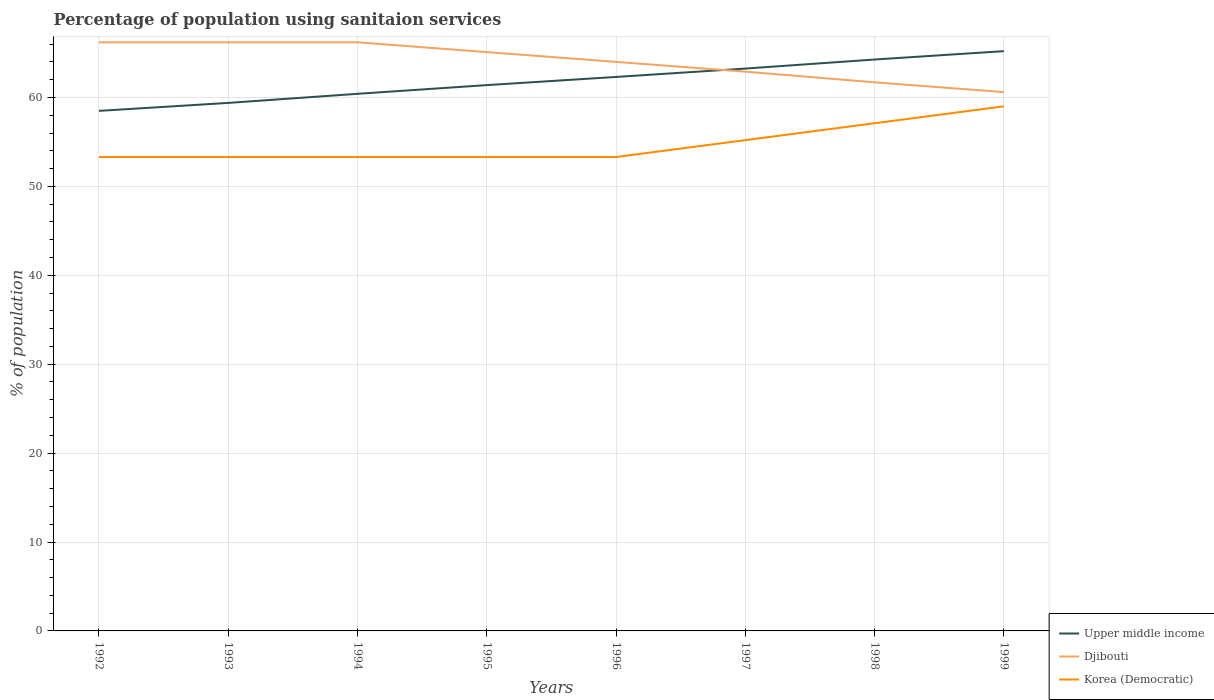How many different coloured lines are there?
Make the answer very short. 3. Across all years, what is the maximum percentage of population using sanitaion services in Djibouti?
Provide a short and direct response. 60.6. What is the total percentage of population using sanitaion services in Djibouti in the graph?
Provide a short and direct response. 5.6. What is the difference between the highest and the second highest percentage of population using sanitaion services in Djibouti?
Offer a terse response. 5.6. What is the difference between the highest and the lowest percentage of population using sanitaion services in Djibouti?
Your response must be concise. 4. How many lines are there?
Offer a terse response. 3. How many years are there in the graph?
Make the answer very short. 8. What is the difference between two consecutive major ticks on the Y-axis?
Your response must be concise. 10. Are the values on the major ticks of Y-axis written in scientific E-notation?
Ensure brevity in your answer.  No. Where does the legend appear in the graph?
Provide a short and direct response. Bottom right. How are the legend labels stacked?
Offer a terse response. Vertical. What is the title of the graph?
Give a very brief answer. Percentage of population using sanitaion services. Does "Paraguay" appear as one of the legend labels in the graph?
Ensure brevity in your answer.  No. What is the label or title of the Y-axis?
Ensure brevity in your answer.  % of population. What is the % of population of Upper middle income in 1992?
Your answer should be very brief. 58.49. What is the % of population of Djibouti in 1992?
Your answer should be very brief. 66.2. What is the % of population of Korea (Democratic) in 1992?
Provide a succinct answer. 53.3. What is the % of population in Upper middle income in 1993?
Offer a terse response. 59.39. What is the % of population in Djibouti in 1993?
Your answer should be compact. 66.2. What is the % of population in Korea (Democratic) in 1993?
Your answer should be compact. 53.3. What is the % of population in Upper middle income in 1994?
Offer a terse response. 60.41. What is the % of population of Djibouti in 1994?
Your response must be concise. 66.2. What is the % of population of Korea (Democratic) in 1994?
Offer a very short reply. 53.3. What is the % of population of Upper middle income in 1995?
Offer a very short reply. 61.39. What is the % of population of Djibouti in 1995?
Keep it short and to the point. 65.1. What is the % of population of Korea (Democratic) in 1995?
Give a very brief answer. 53.3. What is the % of population in Upper middle income in 1996?
Your response must be concise. 62.31. What is the % of population of Korea (Democratic) in 1996?
Provide a short and direct response. 53.3. What is the % of population in Upper middle income in 1997?
Offer a terse response. 63.25. What is the % of population of Djibouti in 1997?
Your response must be concise. 62.9. What is the % of population of Korea (Democratic) in 1997?
Keep it short and to the point. 55.2. What is the % of population in Upper middle income in 1998?
Provide a succinct answer. 64.27. What is the % of population in Djibouti in 1998?
Provide a short and direct response. 61.7. What is the % of population of Korea (Democratic) in 1998?
Your answer should be compact. 57.1. What is the % of population in Upper middle income in 1999?
Your answer should be compact. 65.21. What is the % of population of Djibouti in 1999?
Provide a succinct answer. 60.6. Across all years, what is the maximum % of population in Upper middle income?
Keep it short and to the point. 65.21. Across all years, what is the maximum % of population of Djibouti?
Provide a short and direct response. 66.2. Across all years, what is the minimum % of population of Upper middle income?
Your response must be concise. 58.49. Across all years, what is the minimum % of population in Djibouti?
Make the answer very short. 60.6. Across all years, what is the minimum % of population of Korea (Democratic)?
Your answer should be very brief. 53.3. What is the total % of population of Upper middle income in the graph?
Your answer should be very brief. 494.69. What is the total % of population in Djibouti in the graph?
Your answer should be very brief. 512.9. What is the total % of population of Korea (Democratic) in the graph?
Offer a terse response. 437.8. What is the difference between the % of population of Upper middle income in 1992 and that in 1993?
Make the answer very short. -0.9. What is the difference between the % of population in Djibouti in 1992 and that in 1993?
Ensure brevity in your answer.  0. What is the difference between the % of population of Upper middle income in 1992 and that in 1994?
Offer a very short reply. -1.92. What is the difference between the % of population of Djibouti in 1992 and that in 1994?
Keep it short and to the point. 0. What is the difference between the % of population in Upper middle income in 1992 and that in 1995?
Provide a succinct answer. -2.9. What is the difference between the % of population of Upper middle income in 1992 and that in 1996?
Give a very brief answer. -3.82. What is the difference between the % of population of Djibouti in 1992 and that in 1996?
Give a very brief answer. 2.2. What is the difference between the % of population of Upper middle income in 1992 and that in 1997?
Your response must be concise. -4.76. What is the difference between the % of population in Djibouti in 1992 and that in 1997?
Ensure brevity in your answer.  3.3. What is the difference between the % of population of Upper middle income in 1992 and that in 1998?
Your response must be concise. -5.78. What is the difference between the % of population in Djibouti in 1992 and that in 1998?
Give a very brief answer. 4.5. What is the difference between the % of population of Korea (Democratic) in 1992 and that in 1998?
Your response must be concise. -3.8. What is the difference between the % of population in Upper middle income in 1992 and that in 1999?
Give a very brief answer. -6.72. What is the difference between the % of population of Korea (Democratic) in 1992 and that in 1999?
Your answer should be compact. -5.7. What is the difference between the % of population of Upper middle income in 1993 and that in 1994?
Offer a very short reply. -1.02. What is the difference between the % of population of Upper middle income in 1993 and that in 1995?
Keep it short and to the point. -2. What is the difference between the % of population in Djibouti in 1993 and that in 1995?
Give a very brief answer. 1.1. What is the difference between the % of population of Korea (Democratic) in 1993 and that in 1995?
Make the answer very short. 0. What is the difference between the % of population of Upper middle income in 1993 and that in 1996?
Your response must be concise. -2.92. What is the difference between the % of population of Djibouti in 1993 and that in 1996?
Ensure brevity in your answer.  2.2. What is the difference between the % of population of Korea (Democratic) in 1993 and that in 1996?
Your answer should be compact. 0. What is the difference between the % of population of Upper middle income in 1993 and that in 1997?
Your response must be concise. -3.86. What is the difference between the % of population in Korea (Democratic) in 1993 and that in 1997?
Provide a short and direct response. -1.9. What is the difference between the % of population in Upper middle income in 1993 and that in 1998?
Make the answer very short. -4.88. What is the difference between the % of population in Djibouti in 1993 and that in 1998?
Your answer should be very brief. 4.5. What is the difference between the % of population in Korea (Democratic) in 1993 and that in 1998?
Offer a terse response. -3.8. What is the difference between the % of population of Upper middle income in 1993 and that in 1999?
Make the answer very short. -5.82. What is the difference between the % of population in Djibouti in 1993 and that in 1999?
Offer a very short reply. 5.6. What is the difference between the % of population in Korea (Democratic) in 1993 and that in 1999?
Offer a very short reply. -5.7. What is the difference between the % of population in Upper middle income in 1994 and that in 1995?
Provide a short and direct response. -0.98. What is the difference between the % of population of Upper middle income in 1994 and that in 1996?
Your answer should be very brief. -1.9. What is the difference between the % of population in Djibouti in 1994 and that in 1996?
Keep it short and to the point. 2.2. What is the difference between the % of population of Upper middle income in 1994 and that in 1997?
Ensure brevity in your answer.  -2.84. What is the difference between the % of population in Djibouti in 1994 and that in 1997?
Your response must be concise. 3.3. What is the difference between the % of population in Upper middle income in 1994 and that in 1998?
Your answer should be very brief. -3.86. What is the difference between the % of population in Djibouti in 1994 and that in 1998?
Ensure brevity in your answer.  4.5. What is the difference between the % of population in Upper middle income in 1994 and that in 1999?
Give a very brief answer. -4.8. What is the difference between the % of population in Korea (Democratic) in 1994 and that in 1999?
Keep it short and to the point. -5.7. What is the difference between the % of population of Upper middle income in 1995 and that in 1996?
Offer a very short reply. -0.92. What is the difference between the % of population in Upper middle income in 1995 and that in 1997?
Your response must be concise. -1.86. What is the difference between the % of population in Korea (Democratic) in 1995 and that in 1997?
Offer a very short reply. -1.9. What is the difference between the % of population of Upper middle income in 1995 and that in 1998?
Give a very brief answer. -2.88. What is the difference between the % of population of Korea (Democratic) in 1995 and that in 1998?
Keep it short and to the point. -3.8. What is the difference between the % of population in Upper middle income in 1995 and that in 1999?
Offer a terse response. -3.82. What is the difference between the % of population of Djibouti in 1995 and that in 1999?
Offer a very short reply. 4.5. What is the difference between the % of population of Korea (Democratic) in 1995 and that in 1999?
Provide a succinct answer. -5.7. What is the difference between the % of population of Upper middle income in 1996 and that in 1997?
Offer a very short reply. -0.94. What is the difference between the % of population in Djibouti in 1996 and that in 1997?
Offer a very short reply. 1.1. What is the difference between the % of population in Upper middle income in 1996 and that in 1998?
Your response must be concise. -1.96. What is the difference between the % of population in Djibouti in 1996 and that in 1998?
Your answer should be compact. 2.3. What is the difference between the % of population in Upper middle income in 1996 and that in 1999?
Offer a very short reply. -2.9. What is the difference between the % of population of Korea (Democratic) in 1996 and that in 1999?
Offer a very short reply. -5.7. What is the difference between the % of population of Upper middle income in 1997 and that in 1998?
Your response must be concise. -1.02. What is the difference between the % of population in Upper middle income in 1997 and that in 1999?
Ensure brevity in your answer.  -1.96. What is the difference between the % of population in Korea (Democratic) in 1997 and that in 1999?
Keep it short and to the point. -3.8. What is the difference between the % of population of Upper middle income in 1998 and that in 1999?
Your response must be concise. -0.94. What is the difference between the % of population of Korea (Democratic) in 1998 and that in 1999?
Provide a short and direct response. -1.9. What is the difference between the % of population of Upper middle income in 1992 and the % of population of Djibouti in 1993?
Give a very brief answer. -7.71. What is the difference between the % of population of Upper middle income in 1992 and the % of population of Korea (Democratic) in 1993?
Keep it short and to the point. 5.19. What is the difference between the % of population in Djibouti in 1992 and the % of population in Korea (Democratic) in 1993?
Make the answer very short. 12.9. What is the difference between the % of population in Upper middle income in 1992 and the % of population in Djibouti in 1994?
Provide a succinct answer. -7.71. What is the difference between the % of population of Upper middle income in 1992 and the % of population of Korea (Democratic) in 1994?
Offer a very short reply. 5.19. What is the difference between the % of population of Upper middle income in 1992 and the % of population of Djibouti in 1995?
Your response must be concise. -6.61. What is the difference between the % of population of Upper middle income in 1992 and the % of population of Korea (Democratic) in 1995?
Your answer should be very brief. 5.19. What is the difference between the % of population of Djibouti in 1992 and the % of population of Korea (Democratic) in 1995?
Give a very brief answer. 12.9. What is the difference between the % of population in Upper middle income in 1992 and the % of population in Djibouti in 1996?
Provide a succinct answer. -5.51. What is the difference between the % of population in Upper middle income in 1992 and the % of population in Korea (Democratic) in 1996?
Provide a succinct answer. 5.19. What is the difference between the % of population in Upper middle income in 1992 and the % of population in Djibouti in 1997?
Offer a very short reply. -4.41. What is the difference between the % of population in Upper middle income in 1992 and the % of population in Korea (Democratic) in 1997?
Make the answer very short. 3.29. What is the difference between the % of population of Djibouti in 1992 and the % of population of Korea (Democratic) in 1997?
Offer a terse response. 11. What is the difference between the % of population in Upper middle income in 1992 and the % of population in Djibouti in 1998?
Offer a very short reply. -3.21. What is the difference between the % of population in Upper middle income in 1992 and the % of population in Korea (Democratic) in 1998?
Provide a succinct answer. 1.39. What is the difference between the % of population in Djibouti in 1992 and the % of population in Korea (Democratic) in 1998?
Your response must be concise. 9.1. What is the difference between the % of population of Upper middle income in 1992 and the % of population of Djibouti in 1999?
Ensure brevity in your answer.  -2.11. What is the difference between the % of population in Upper middle income in 1992 and the % of population in Korea (Democratic) in 1999?
Give a very brief answer. -0.51. What is the difference between the % of population of Djibouti in 1992 and the % of population of Korea (Democratic) in 1999?
Make the answer very short. 7.2. What is the difference between the % of population in Upper middle income in 1993 and the % of population in Djibouti in 1994?
Keep it short and to the point. -6.81. What is the difference between the % of population of Upper middle income in 1993 and the % of population of Korea (Democratic) in 1994?
Make the answer very short. 6.09. What is the difference between the % of population of Djibouti in 1993 and the % of population of Korea (Democratic) in 1994?
Your answer should be compact. 12.9. What is the difference between the % of population of Upper middle income in 1993 and the % of population of Djibouti in 1995?
Give a very brief answer. -5.71. What is the difference between the % of population in Upper middle income in 1993 and the % of population in Korea (Democratic) in 1995?
Make the answer very short. 6.09. What is the difference between the % of population in Upper middle income in 1993 and the % of population in Djibouti in 1996?
Offer a terse response. -4.61. What is the difference between the % of population of Upper middle income in 1993 and the % of population of Korea (Democratic) in 1996?
Your answer should be very brief. 6.09. What is the difference between the % of population of Djibouti in 1993 and the % of population of Korea (Democratic) in 1996?
Ensure brevity in your answer.  12.9. What is the difference between the % of population in Upper middle income in 1993 and the % of population in Djibouti in 1997?
Keep it short and to the point. -3.51. What is the difference between the % of population in Upper middle income in 1993 and the % of population in Korea (Democratic) in 1997?
Give a very brief answer. 4.19. What is the difference between the % of population in Upper middle income in 1993 and the % of population in Djibouti in 1998?
Make the answer very short. -2.31. What is the difference between the % of population of Upper middle income in 1993 and the % of population of Korea (Democratic) in 1998?
Your answer should be very brief. 2.29. What is the difference between the % of population in Upper middle income in 1993 and the % of population in Djibouti in 1999?
Offer a very short reply. -1.21. What is the difference between the % of population in Upper middle income in 1993 and the % of population in Korea (Democratic) in 1999?
Your answer should be very brief. 0.39. What is the difference between the % of population in Djibouti in 1993 and the % of population in Korea (Democratic) in 1999?
Offer a terse response. 7.2. What is the difference between the % of population in Upper middle income in 1994 and the % of population in Djibouti in 1995?
Give a very brief answer. -4.69. What is the difference between the % of population of Upper middle income in 1994 and the % of population of Korea (Democratic) in 1995?
Ensure brevity in your answer.  7.11. What is the difference between the % of population of Upper middle income in 1994 and the % of population of Djibouti in 1996?
Offer a very short reply. -3.59. What is the difference between the % of population of Upper middle income in 1994 and the % of population of Korea (Democratic) in 1996?
Keep it short and to the point. 7.11. What is the difference between the % of population of Upper middle income in 1994 and the % of population of Djibouti in 1997?
Make the answer very short. -2.49. What is the difference between the % of population in Upper middle income in 1994 and the % of population in Korea (Democratic) in 1997?
Your answer should be very brief. 5.21. What is the difference between the % of population in Upper middle income in 1994 and the % of population in Djibouti in 1998?
Provide a succinct answer. -1.29. What is the difference between the % of population in Upper middle income in 1994 and the % of population in Korea (Democratic) in 1998?
Ensure brevity in your answer.  3.31. What is the difference between the % of population in Upper middle income in 1994 and the % of population in Djibouti in 1999?
Keep it short and to the point. -0.19. What is the difference between the % of population of Upper middle income in 1994 and the % of population of Korea (Democratic) in 1999?
Provide a short and direct response. 1.41. What is the difference between the % of population in Upper middle income in 1995 and the % of population in Djibouti in 1996?
Ensure brevity in your answer.  -2.61. What is the difference between the % of population of Upper middle income in 1995 and the % of population of Korea (Democratic) in 1996?
Ensure brevity in your answer.  8.09. What is the difference between the % of population of Djibouti in 1995 and the % of population of Korea (Democratic) in 1996?
Ensure brevity in your answer.  11.8. What is the difference between the % of population of Upper middle income in 1995 and the % of population of Djibouti in 1997?
Give a very brief answer. -1.51. What is the difference between the % of population in Upper middle income in 1995 and the % of population in Korea (Democratic) in 1997?
Offer a terse response. 6.19. What is the difference between the % of population in Upper middle income in 1995 and the % of population in Djibouti in 1998?
Your response must be concise. -0.31. What is the difference between the % of population in Upper middle income in 1995 and the % of population in Korea (Democratic) in 1998?
Give a very brief answer. 4.29. What is the difference between the % of population in Upper middle income in 1995 and the % of population in Djibouti in 1999?
Offer a terse response. 0.79. What is the difference between the % of population of Upper middle income in 1995 and the % of population of Korea (Democratic) in 1999?
Provide a succinct answer. 2.39. What is the difference between the % of population in Djibouti in 1995 and the % of population in Korea (Democratic) in 1999?
Your answer should be compact. 6.1. What is the difference between the % of population of Upper middle income in 1996 and the % of population of Djibouti in 1997?
Offer a very short reply. -0.59. What is the difference between the % of population of Upper middle income in 1996 and the % of population of Korea (Democratic) in 1997?
Offer a very short reply. 7.11. What is the difference between the % of population of Upper middle income in 1996 and the % of population of Djibouti in 1998?
Your answer should be compact. 0.61. What is the difference between the % of population in Upper middle income in 1996 and the % of population in Korea (Democratic) in 1998?
Provide a succinct answer. 5.21. What is the difference between the % of population in Upper middle income in 1996 and the % of population in Djibouti in 1999?
Provide a succinct answer. 1.71. What is the difference between the % of population of Upper middle income in 1996 and the % of population of Korea (Democratic) in 1999?
Keep it short and to the point. 3.31. What is the difference between the % of population of Upper middle income in 1997 and the % of population of Djibouti in 1998?
Keep it short and to the point. 1.55. What is the difference between the % of population in Upper middle income in 1997 and the % of population in Korea (Democratic) in 1998?
Provide a short and direct response. 6.15. What is the difference between the % of population of Djibouti in 1997 and the % of population of Korea (Democratic) in 1998?
Offer a very short reply. 5.8. What is the difference between the % of population of Upper middle income in 1997 and the % of population of Djibouti in 1999?
Provide a succinct answer. 2.65. What is the difference between the % of population in Upper middle income in 1997 and the % of population in Korea (Democratic) in 1999?
Give a very brief answer. 4.25. What is the difference between the % of population of Djibouti in 1997 and the % of population of Korea (Democratic) in 1999?
Make the answer very short. 3.9. What is the difference between the % of population of Upper middle income in 1998 and the % of population of Djibouti in 1999?
Make the answer very short. 3.67. What is the difference between the % of population of Upper middle income in 1998 and the % of population of Korea (Democratic) in 1999?
Your answer should be very brief. 5.27. What is the difference between the % of population of Djibouti in 1998 and the % of population of Korea (Democratic) in 1999?
Make the answer very short. 2.7. What is the average % of population of Upper middle income per year?
Keep it short and to the point. 61.84. What is the average % of population in Djibouti per year?
Keep it short and to the point. 64.11. What is the average % of population in Korea (Democratic) per year?
Make the answer very short. 54.73. In the year 1992, what is the difference between the % of population of Upper middle income and % of population of Djibouti?
Your answer should be very brief. -7.71. In the year 1992, what is the difference between the % of population of Upper middle income and % of population of Korea (Democratic)?
Your answer should be compact. 5.19. In the year 1993, what is the difference between the % of population in Upper middle income and % of population in Djibouti?
Your answer should be very brief. -6.81. In the year 1993, what is the difference between the % of population of Upper middle income and % of population of Korea (Democratic)?
Offer a very short reply. 6.09. In the year 1994, what is the difference between the % of population in Upper middle income and % of population in Djibouti?
Your response must be concise. -5.79. In the year 1994, what is the difference between the % of population in Upper middle income and % of population in Korea (Democratic)?
Offer a terse response. 7.11. In the year 1994, what is the difference between the % of population of Djibouti and % of population of Korea (Democratic)?
Your answer should be compact. 12.9. In the year 1995, what is the difference between the % of population of Upper middle income and % of population of Djibouti?
Your answer should be compact. -3.71. In the year 1995, what is the difference between the % of population of Upper middle income and % of population of Korea (Democratic)?
Provide a succinct answer. 8.09. In the year 1996, what is the difference between the % of population of Upper middle income and % of population of Djibouti?
Your response must be concise. -1.69. In the year 1996, what is the difference between the % of population in Upper middle income and % of population in Korea (Democratic)?
Your answer should be very brief. 9.01. In the year 1996, what is the difference between the % of population of Djibouti and % of population of Korea (Democratic)?
Offer a very short reply. 10.7. In the year 1997, what is the difference between the % of population of Upper middle income and % of population of Djibouti?
Offer a terse response. 0.35. In the year 1997, what is the difference between the % of population of Upper middle income and % of population of Korea (Democratic)?
Offer a very short reply. 8.05. In the year 1997, what is the difference between the % of population in Djibouti and % of population in Korea (Democratic)?
Keep it short and to the point. 7.7. In the year 1998, what is the difference between the % of population of Upper middle income and % of population of Djibouti?
Keep it short and to the point. 2.57. In the year 1998, what is the difference between the % of population in Upper middle income and % of population in Korea (Democratic)?
Keep it short and to the point. 7.17. In the year 1999, what is the difference between the % of population of Upper middle income and % of population of Djibouti?
Your answer should be very brief. 4.61. In the year 1999, what is the difference between the % of population of Upper middle income and % of population of Korea (Democratic)?
Ensure brevity in your answer.  6.21. In the year 1999, what is the difference between the % of population of Djibouti and % of population of Korea (Democratic)?
Your answer should be very brief. 1.6. What is the ratio of the % of population in Upper middle income in 1992 to that in 1993?
Your answer should be very brief. 0.98. What is the ratio of the % of population of Djibouti in 1992 to that in 1993?
Offer a very short reply. 1. What is the ratio of the % of population in Korea (Democratic) in 1992 to that in 1993?
Your answer should be very brief. 1. What is the ratio of the % of population of Upper middle income in 1992 to that in 1994?
Provide a short and direct response. 0.97. What is the ratio of the % of population in Djibouti in 1992 to that in 1994?
Provide a succinct answer. 1. What is the ratio of the % of population in Upper middle income in 1992 to that in 1995?
Your answer should be compact. 0.95. What is the ratio of the % of population of Djibouti in 1992 to that in 1995?
Offer a very short reply. 1.02. What is the ratio of the % of population in Korea (Democratic) in 1992 to that in 1995?
Your answer should be very brief. 1. What is the ratio of the % of population in Upper middle income in 1992 to that in 1996?
Make the answer very short. 0.94. What is the ratio of the % of population of Djibouti in 1992 to that in 1996?
Your answer should be very brief. 1.03. What is the ratio of the % of population in Korea (Democratic) in 1992 to that in 1996?
Provide a succinct answer. 1. What is the ratio of the % of population in Upper middle income in 1992 to that in 1997?
Make the answer very short. 0.92. What is the ratio of the % of population in Djibouti in 1992 to that in 1997?
Give a very brief answer. 1.05. What is the ratio of the % of population in Korea (Democratic) in 1992 to that in 1997?
Offer a terse response. 0.97. What is the ratio of the % of population of Upper middle income in 1992 to that in 1998?
Your answer should be very brief. 0.91. What is the ratio of the % of population in Djibouti in 1992 to that in 1998?
Your answer should be compact. 1.07. What is the ratio of the % of population of Korea (Democratic) in 1992 to that in 1998?
Your response must be concise. 0.93. What is the ratio of the % of population in Upper middle income in 1992 to that in 1999?
Give a very brief answer. 0.9. What is the ratio of the % of population of Djibouti in 1992 to that in 1999?
Give a very brief answer. 1.09. What is the ratio of the % of population of Korea (Democratic) in 1992 to that in 1999?
Offer a terse response. 0.9. What is the ratio of the % of population in Upper middle income in 1993 to that in 1994?
Your answer should be very brief. 0.98. What is the ratio of the % of population in Korea (Democratic) in 1993 to that in 1994?
Offer a very short reply. 1. What is the ratio of the % of population in Upper middle income in 1993 to that in 1995?
Offer a very short reply. 0.97. What is the ratio of the % of population of Djibouti in 1993 to that in 1995?
Offer a very short reply. 1.02. What is the ratio of the % of population in Korea (Democratic) in 1993 to that in 1995?
Ensure brevity in your answer.  1. What is the ratio of the % of population of Upper middle income in 1993 to that in 1996?
Your answer should be very brief. 0.95. What is the ratio of the % of population in Djibouti in 1993 to that in 1996?
Your answer should be compact. 1.03. What is the ratio of the % of population of Korea (Democratic) in 1993 to that in 1996?
Give a very brief answer. 1. What is the ratio of the % of population of Upper middle income in 1993 to that in 1997?
Provide a short and direct response. 0.94. What is the ratio of the % of population of Djibouti in 1993 to that in 1997?
Offer a terse response. 1.05. What is the ratio of the % of population in Korea (Democratic) in 1993 to that in 1997?
Your answer should be very brief. 0.97. What is the ratio of the % of population of Upper middle income in 1993 to that in 1998?
Your answer should be very brief. 0.92. What is the ratio of the % of population of Djibouti in 1993 to that in 1998?
Make the answer very short. 1.07. What is the ratio of the % of population in Korea (Democratic) in 1993 to that in 1998?
Offer a terse response. 0.93. What is the ratio of the % of population of Upper middle income in 1993 to that in 1999?
Your answer should be compact. 0.91. What is the ratio of the % of population of Djibouti in 1993 to that in 1999?
Provide a succinct answer. 1.09. What is the ratio of the % of population of Korea (Democratic) in 1993 to that in 1999?
Offer a terse response. 0.9. What is the ratio of the % of population in Djibouti in 1994 to that in 1995?
Your response must be concise. 1.02. What is the ratio of the % of population of Upper middle income in 1994 to that in 1996?
Ensure brevity in your answer.  0.97. What is the ratio of the % of population in Djibouti in 1994 to that in 1996?
Offer a very short reply. 1.03. What is the ratio of the % of population of Upper middle income in 1994 to that in 1997?
Your response must be concise. 0.96. What is the ratio of the % of population of Djibouti in 1994 to that in 1997?
Offer a terse response. 1.05. What is the ratio of the % of population in Korea (Democratic) in 1994 to that in 1997?
Your answer should be very brief. 0.97. What is the ratio of the % of population of Djibouti in 1994 to that in 1998?
Your response must be concise. 1.07. What is the ratio of the % of population in Korea (Democratic) in 1994 to that in 1998?
Keep it short and to the point. 0.93. What is the ratio of the % of population in Upper middle income in 1994 to that in 1999?
Your response must be concise. 0.93. What is the ratio of the % of population of Djibouti in 1994 to that in 1999?
Your answer should be very brief. 1.09. What is the ratio of the % of population in Korea (Democratic) in 1994 to that in 1999?
Keep it short and to the point. 0.9. What is the ratio of the % of population of Upper middle income in 1995 to that in 1996?
Make the answer very short. 0.99. What is the ratio of the % of population in Djibouti in 1995 to that in 1996?
Keep it short and to the point. 1.02. What is the ratio of the % of population of Upper middle income in 1995 to that in 1997?
Give a very brief answer. 0.97. What is the ratio of the % of population in Djibouti in 1995 to that in 1997?
Offer a terse response. 1.03. What is the ratio of the % of population in Korea (Democratic) in 1995 to that in 1997?
Make the answer very short. 0.97. What is the ratio of the % of population in Upper middle income in 1995 to that in 1998?
Provide a succinct answer. 0.96. What is the ratio of the % of population in Djibouti in 1995 to that in 1998?
Your answer should be very brief. 1.06. What is the ratio of the % of population of Korea (Democratic) in 1995 to that in 1998?
Your answer should be compact. 0.93. What is the ratio of the % of population in Upper middle income in 1995 to that in 1999?
Your answer should be compact. 0.94. What is the ratio of the % of population in Djibouti in 1995 to that in 1999?
Make the answer very short. 1.07. What is the ratio of the % of population in Korea (Democratic) in 1995 to that in 1999?
Your answer should be very brief. 0.9. What is the ratio of the % of population in Upper middle income in 1996 to that in 1997?
Your response must be concise. 0.99. What is the ratio of the % of population in Djibouti in 1996 to that in 1997?
Make the answer very short. 1.02. What is the ratio of the % of population in Korea (Democratic) in 1996 to that in 1997?
Offer a terse response. 0.97. What is the ratio of the % of population of Upper middle income in 1996 to that in 1998?
Give a very brief answer. 0.97. What is the ratio of the % of population of Djibouti in 1996 to that in 1998?
Provide a short and direct response. 1.04. What is the ratio of the % of population in Korea (Democratic) in 1996 to that in 1998?
Give a very brief answer. 0.93. What is the ratio of the % of population of Upper middle income in 1996 to that in 1999?
Your response must be concise. 0.96. What is the ratio of the % of population in Djibouti in 1996 to that in 1999?
Offer a terse response. 1.06. What is the ratio of the % of population of Korea (Democratic) in 1996 to that in 1999?
Ensure brevity in your answer.  0.9. What is the ratio of the % of population in Upper middle income in 1997 to that in 1998?
Keep it short and to the point. 0.98. What is the ratio of the % of population of Djibouti in 1997 to that in 1998?
Your answer should be very brief. 1.02. What is the ratio of the % of population in Korea (Democratic) in 1997 to that in 1998?
Your answer should be very brief. 0.97. What is the ratio of the % of population in Upper middle income in 1997 to that in 1999?
Give a very brief answer. 0.97. What is the ratio of the % of population in Djibouti in 1997 to that in 1999?
Your response must be concise. 1.04. What is the ratio of the % of population in Korea (Democratic) in 1997 to that in 1999?
Your response must be concise. 0.94. What is the ratio of the % of population of Upper middle income in 1998 to that in 1999?
Provide a succinct answer. 0.99. What is the ratio of the % of population of Djibouti in 1998 to that in 1999?
Keep it short and to the point. 1.02. What is the ratio of the % of population in Korea (Democratic) in 1998 to that in 1999?
Offer a very short reply. 0.97. What is the difference between the highest and the second highest % of population of Upper middle income?
Provide a short and direct response. 0.94. What is the difference between the highest and the second highest % of population in Djibouti?
Offer a terse response. 0. What is the difference between the highest and the second highest % of population in Korea (Democratic)?
Make the answer very short. 1.9. What is the difference between the highest and the lowest % of population of Upper middle income?
Ensure brevity in your answer.  6.72. What is the difference between the highest and the lowest % of population of Djibouti?
Keep it short and to the point. 5.6. What is the difference between the highest and the lowest % of population of Korea (Democratic)?
Make the answer very short. 5.7. 